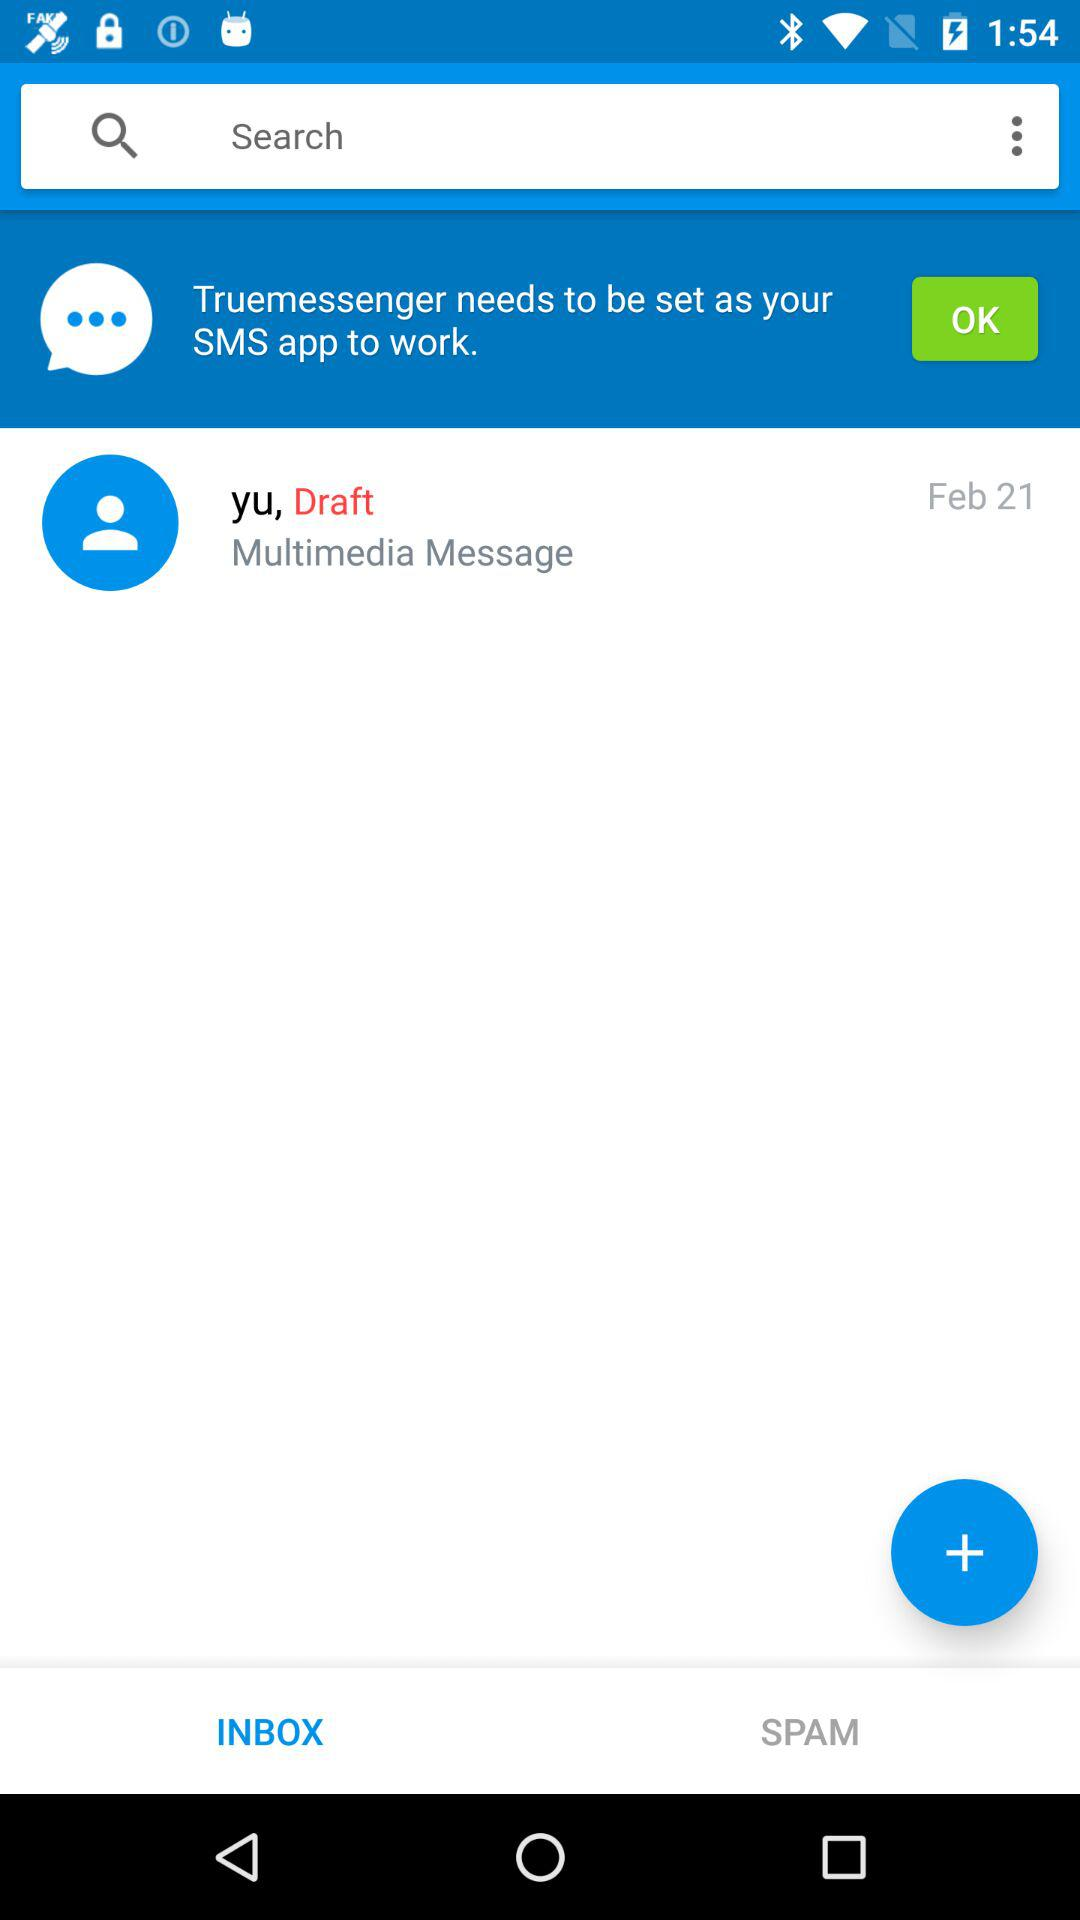Which tab is currently selected? The currently selected tab is "INBOX". 